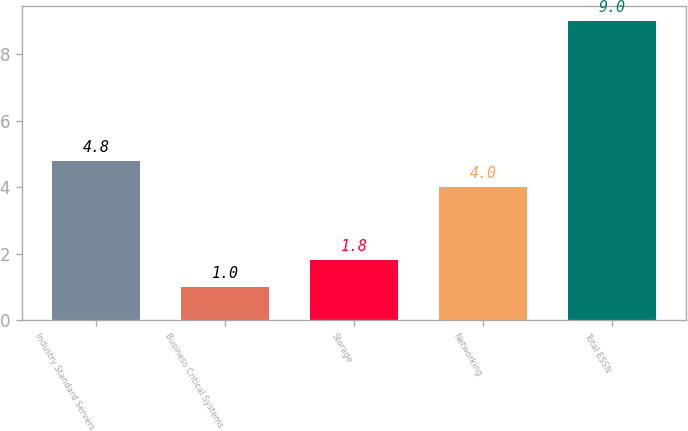<chart> <loc_0><loc_0><loc_500><loc_500><bar_chart><fcel>Industry Standard Servers<fcel>Business Critical Systems<fcel>Storage<fcel>Networking<fcel>Total ESSN<nl><fcel>4.8<fcel>1<fcel>1.8<fcel>4<fcel>9<nl></chart> 